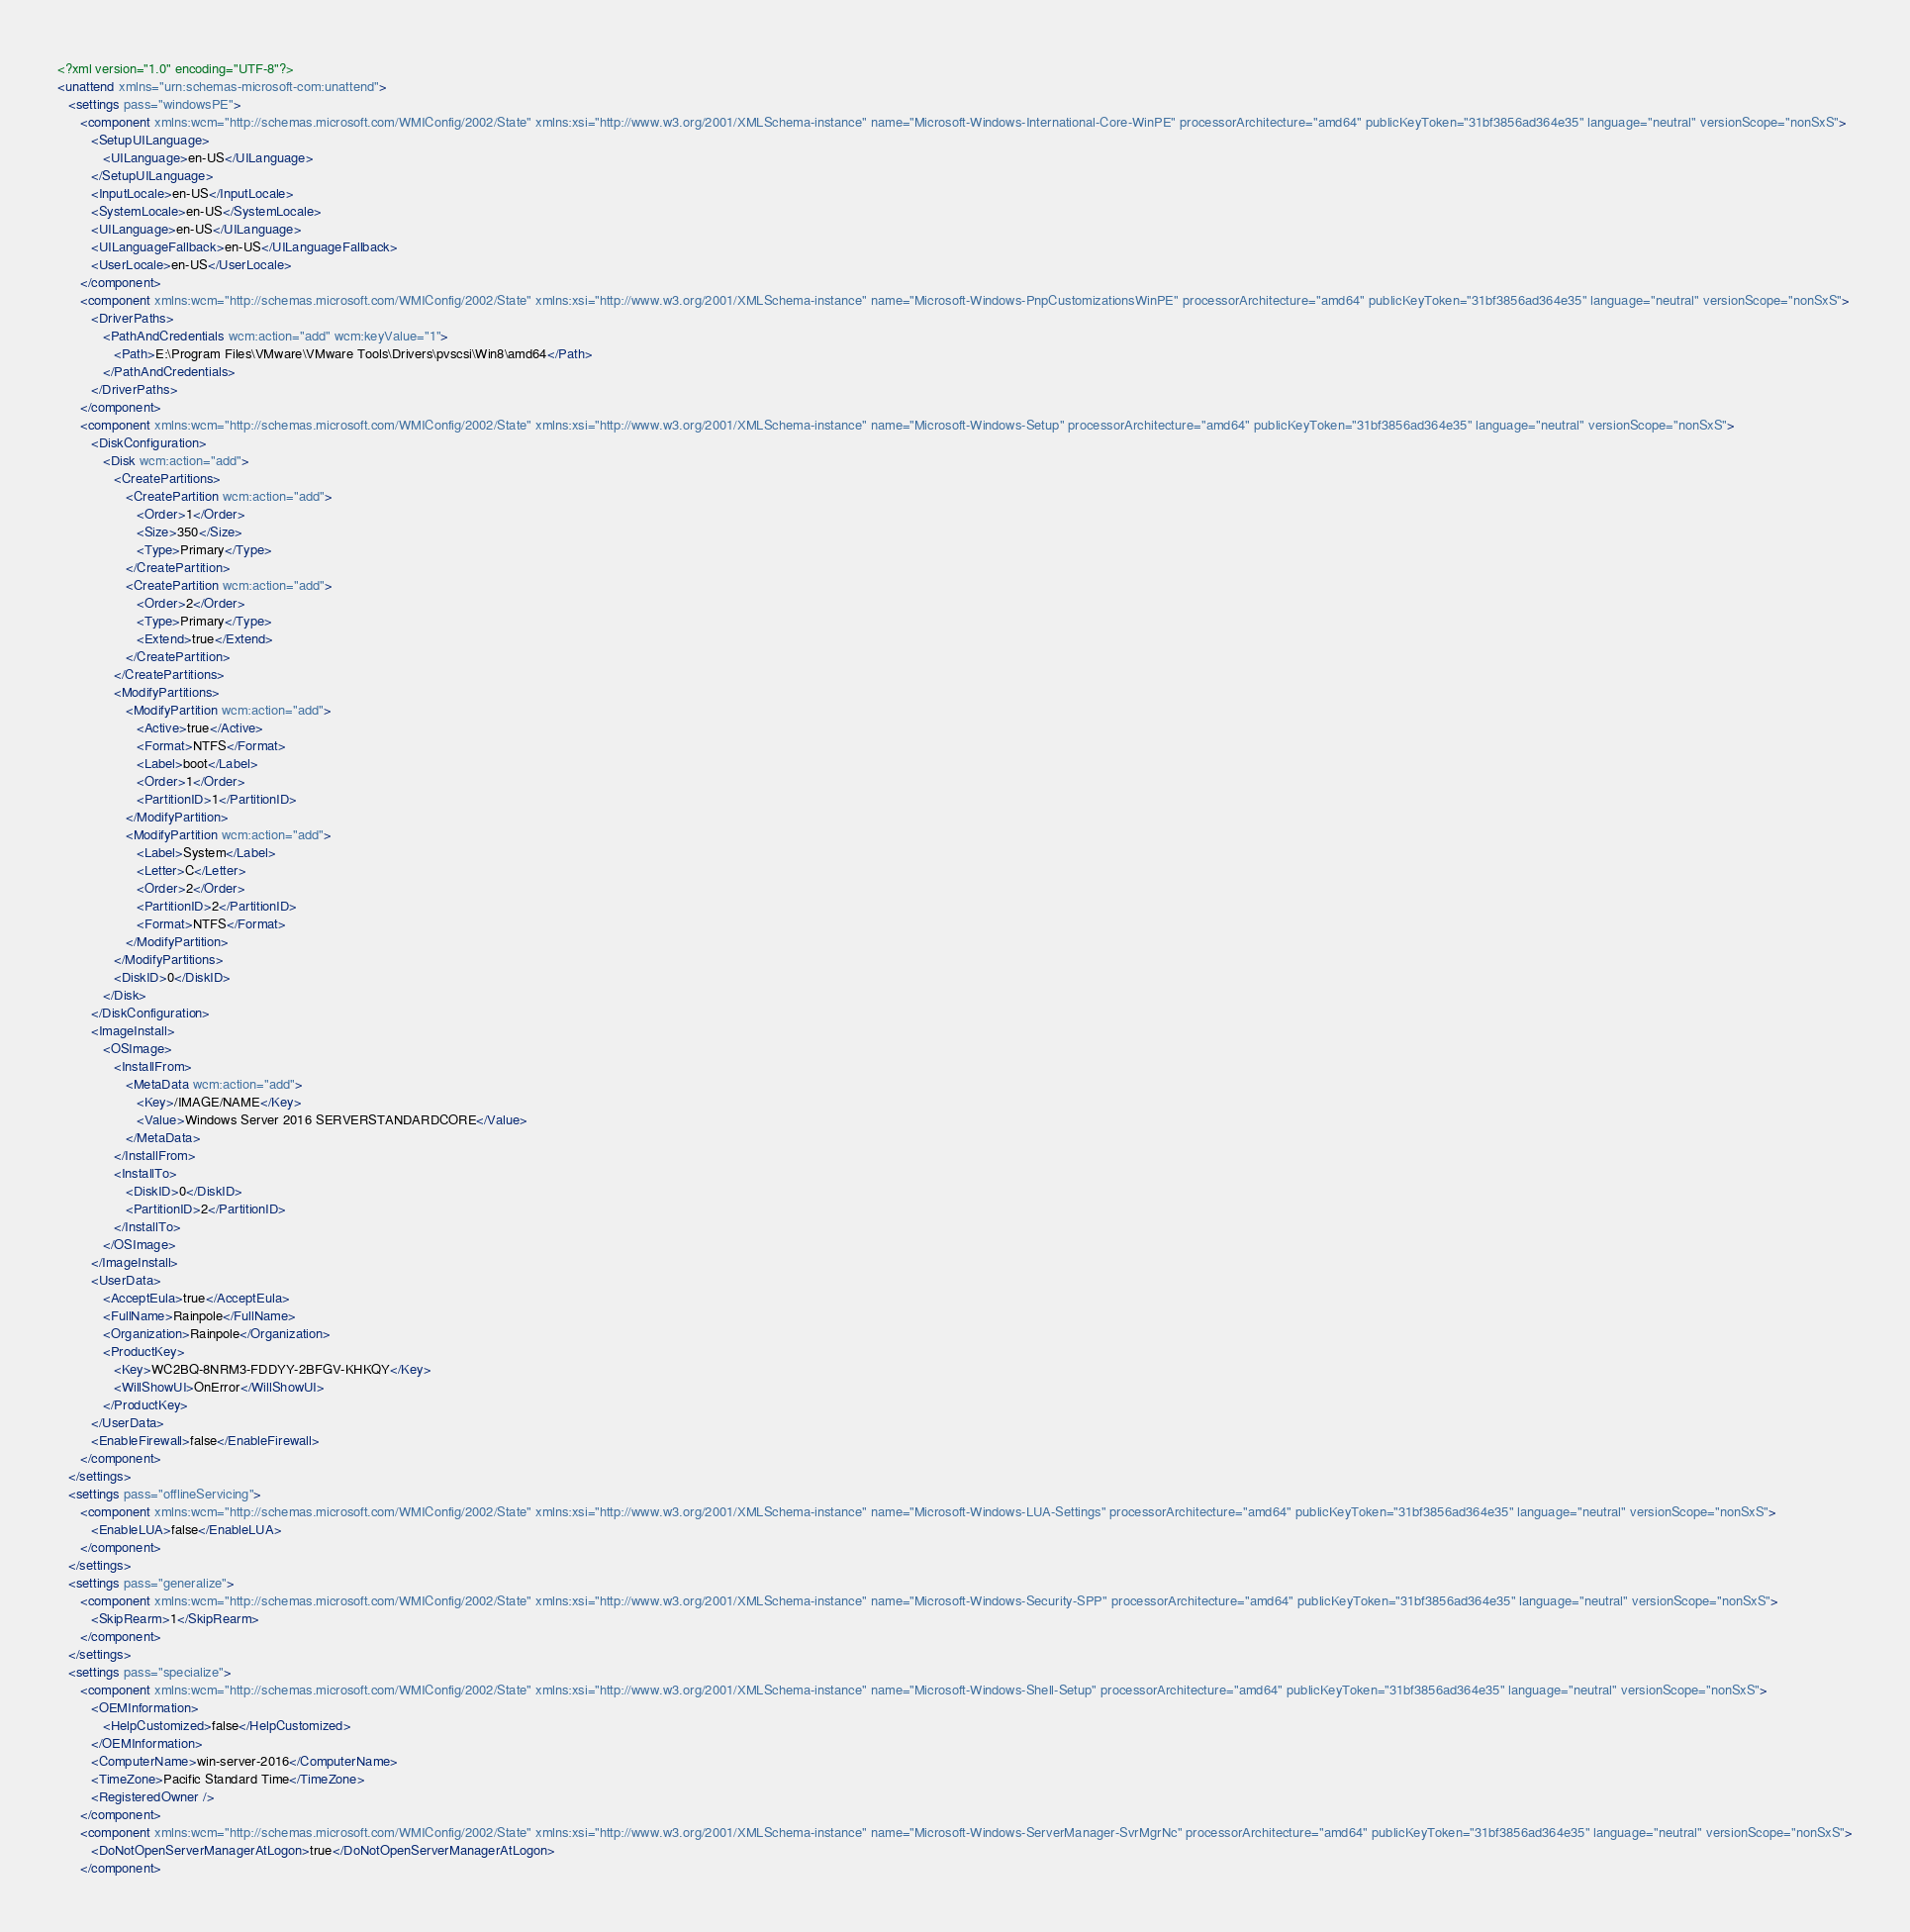Convert code to text. <code><loc_0><loc_0><loc_500><loc_500><_XML_><?xml version="1.0" encoding="UTF-8"?>
<unattend xmlns="urn:schemas-microsoft-com:unattend">
   <settings pass="windowsPE">
      <component xmlns:wcm="http://schemas.microsoft.com/WMIConfig/2002/State" xmlns:xsi="http://www.w3.org/2001/XMLSchema-instance" name="Microsoft-Windows-International-Core-WinPE" processorArchitecture="amd64" publicKeyToken="31bf3856ad364e35" language="neutral" versionScope="nonSxS">
         <SetupUILanguage>
            <UILanguage>en-US</UILanguage>
         </SetupUILanguage>
         <InputLocale>en-US</InputLocale>
         <SystemLocale>en-US</SystemLocale>
         <UILanguage>en-US</UILanguage>
         <UILanguageFallback>en-US</UILanguageFallback>
         <UserLocale>en-US</UserLocale>
      </component>
      <component xmlns:wcm="http://schemas.microsoft.com/WMIConfig/2002/State" xmlns:xsi="http://www.w3.org/2001/XMLSchema-instance" name="Microsoft-Windows-PnpCustomizationsWinPE" processorArchitecture="amd64" publicKeyToken="31bf3856ad364e35" language="neutral" versionScope="nonSxS">
         <DriverPaths>
            <PathAndCredentials wcm:action="add" wcm:keyValue="1">
               <Path>E:\Program Files\VMware\VMware Tools\Drivers\pvscsi\Win8\amd64</Path>
            </PathAndCredentials>
         </DriverPaths>
      </component>
      <component xmlns:wcm="http://schemas.microsoft.com/WMIConfig/2002/State" xmlns:xsi="http://www.w3.org/2001/XMLSchema-instance" name="Microsoft-Windows-Setup" processorArchitecture="amd64" publicKeyToken="31bf3856ad364e35" language="neutral" versionScope="nonSxS">
         <DiskConfiguration>
            <Disk wcm:action="add">
               <CreatePartitions>
                  <CreatePartition wcm:action="add">
                     <Order>1</Order>
                     <Size>350</Size>
                     <Type>Primary</Type>
                  </CreatePartition>
                  <CreatePartition wcm:action="add">
                     <Order>2</Order>
                     <Type>Primary</Type>
                     <Extend>true</Extend>
                  </CreatePartition>
               </CreatePartitions>
               <ModifyPartitions>
                  <ModifyPartition wcm:action="add">
                     <Active>true</Active>
                     <Format>NTFS</Format>
                     <Label>boot</Label>
                     <Order>1</Order>
                     <PartitionID>1</PartitionID>
                  </ModifyPartition>
                  <ModifyPartition wcm:action="add">
                     <Label>System</Label>
                     <Letter>C</Letter>
                     <Order>2</Order>
                     <PartitionID>2</PartitionID>
                     <Format>NTFS</Format>
                  </ModifyPartition>
               </ModifyPartitions>
               <DiskID>0</DiskID>
            </Disk>
         </DiskConfiguration>
         <ImageInstall>
            <OSImage>
               <InstallFrom>
                  <MetaData wcm:action="add">
                     <Key>/IMAGE/NAME</Key>
                     <Value>Windows Server 2016 SERVERSTANDARDCORE</Value>
                  </MetaData>
               </InstallFrom>
               <InstallTo>
                  <DiskID>0</DiskID>
                  <PartitionID>2</PartitionID>
               </InstallTo>
            </OSImage>
         </ImageInstall>
         <UserData>
            <AcceptEula>true</AcceptEula>
            <FullName>Rainpole</FullName>
            <Organization>Rainpole</Organization>
            <ProductKey>
               <Key>WC2BQ-8NRM3-FDDYY-2BFGV-KHKQY</Key>
               <WillShowUI>OnError</WillShowUI>
            </ProductKey>
         </UserData>
         <EnableFirewall>false</EnableFirewall>
      </component>
   </settings>
   <settings pass="offlineServicing">
      <component xmlns:wcm="http://schemas.microsoft.com/WMIConfig/2002/State" xmlns:xsi="http://www.w3.org/2001/XMLSchema-instance" name="Microsoft-Windows-LUA-Settings" processorArchitecture="amd64" publicKeyToken="31bf3856ad364e35" language="neutral" versionScope="nonSxS">
         <EnableLUA>false</EnableLUA>
      </component>
   </settings>
   <settings pass="generalize">
      <component xmlns:wcm="http://schemas.microsoft.com/WMIConfig/2002/State" xmlns:xsi="http://www.w3.org/2001/XMLSchema-instance" name="Microsoft-Windows-Security-SPP" processorArchitecture="amd64" publicKeyToken="31bf3856ad364e35" language="neutral" versionScope="nonSxS">
         <SkipRearm>1</SkipRearm>
      </component>
   </settings>
   <settings pass="specialize">
      <component xmlns:wcm="http://schemas.microsoft.com/WMIConfig/2002/State" xmlns:xsi="http://www.w3.org/2001/XMLSchema-instance" name="Microsoft-Windows-Shell-Setup" processorArchitecture="amd64" publicKeyToken="31bf3856ad364e35" language="neutral" versionScope="nonSxS">
         <OEMInformation>
            <HelpCustomized>false</HelpCustomized>
         </OEMInformation>
         <ComputerName>win-server-2016</ComputerName>
         <TimeZone>Pacific Standard Time</TimeZone>
         <RegisteredOwner />
      </component>
      <component xmlns:wcm="http://schemas.microsoft.com/WMIConfig/2002/State" xmlns:xsi="http://www.w3.org/2001/XMLSchema-instance" name="Microsoft-Windows-ServerManager-SvrMgrNc" processorArchitecture="amd64" publicKeyToken="31bf3856ad364e35" language="neutral" versionScope="nonSxS">
         <DoNotOpenServerManagerAtLogon>true</DoNotOpenServerManagerAtLogon>
      </component></code> 